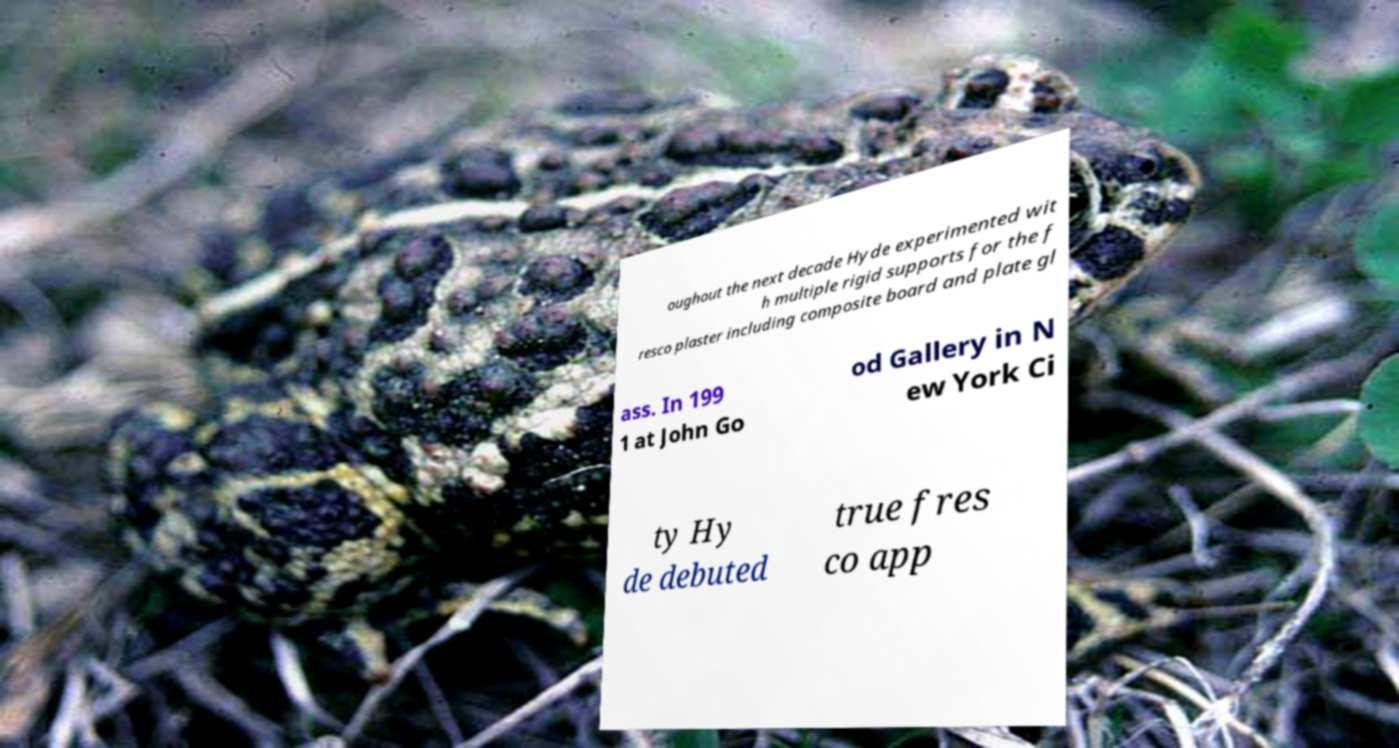Can you read and provide the text displayed in the image?This photo seems to have some interesting text. Can you extract and type it out for me? oughout the next decade Hyde experimented wit h multiple rigid supports for the f resco plaster including composite board and plate gl ass. In 199 1 at John Go od Gallery in N ew York Ci ty Hy de debuted true fres co app 